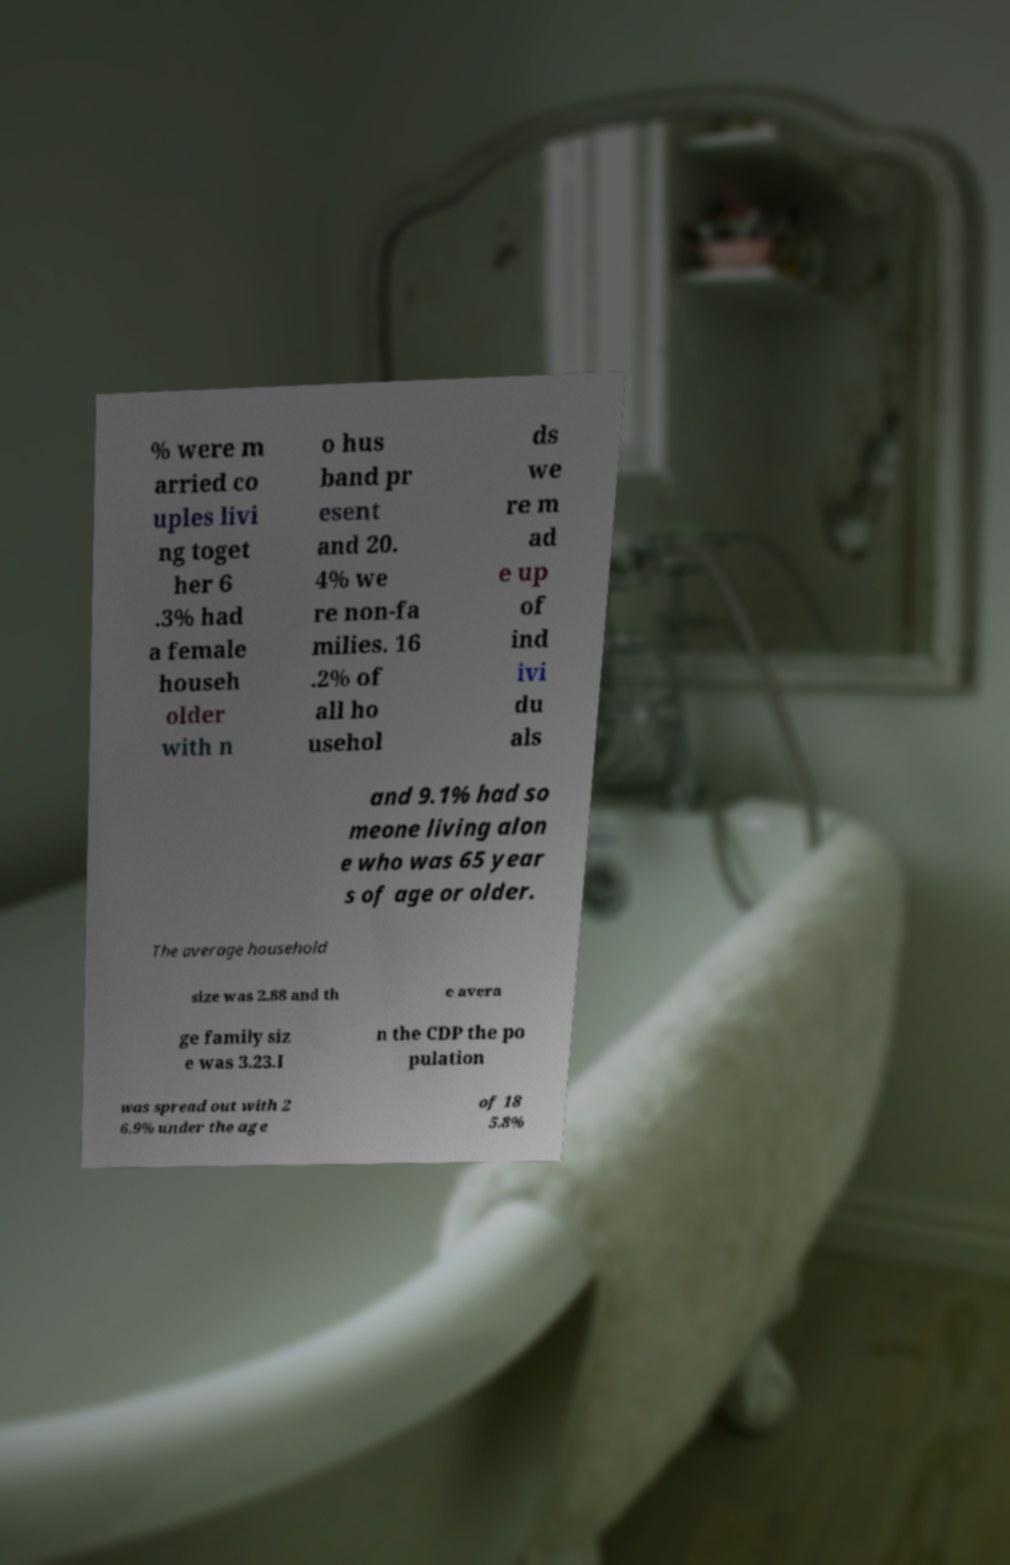Can you accurately transcribe the text from the provided image for me? % were m arried co uples livi ng toget her 6 .3% had a female househ older with n o hus band pr esent and 20. 4% we re non-fa milies. 16 .2% of all ho usehol ds we re m ad e up of ind ivi du als and 9.1% had so meone living alon e who was 65 year s of age or older. The average household size was 2.88 and th e avera ge family siz e was 3.23.I n the CDP the po pulation was spread out with 2 6.9% under the age of 18 5.8% 